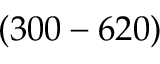<formula> <loc_0><loc_0><loc_500><loc_500>( 3 0 0 - 6 2 0 )</formula> 